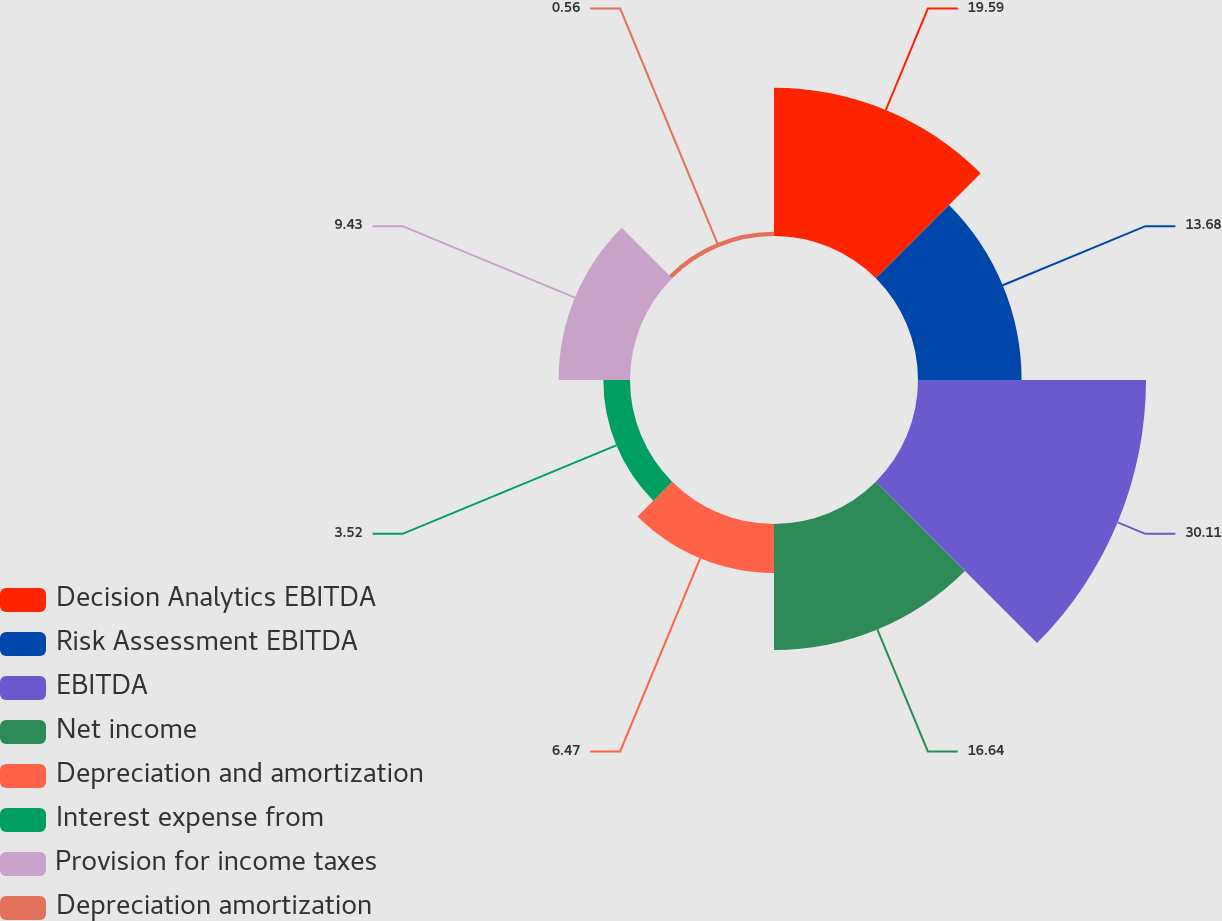Convert chart. <chart><loc_0><loc_0><loc_500><loc_500><pie_chart><fcel>Decision Analytics EBITDA<fcel>Risk Assessment EBITDA<fcel>EBITDA<fcel>Net income<fcel>Depreciation and amortization<fcel>Interest expense from<fcel>Provision for income taxes<fcel>Depreciation amortization<nl><fcel>19.59%<fcel>13.68%<fcel>30.11%<fcel>16.64%<fcel>6.47%<fcel>3.52%<fcel>9.43%<fcel>0.56%<nl></chart> 